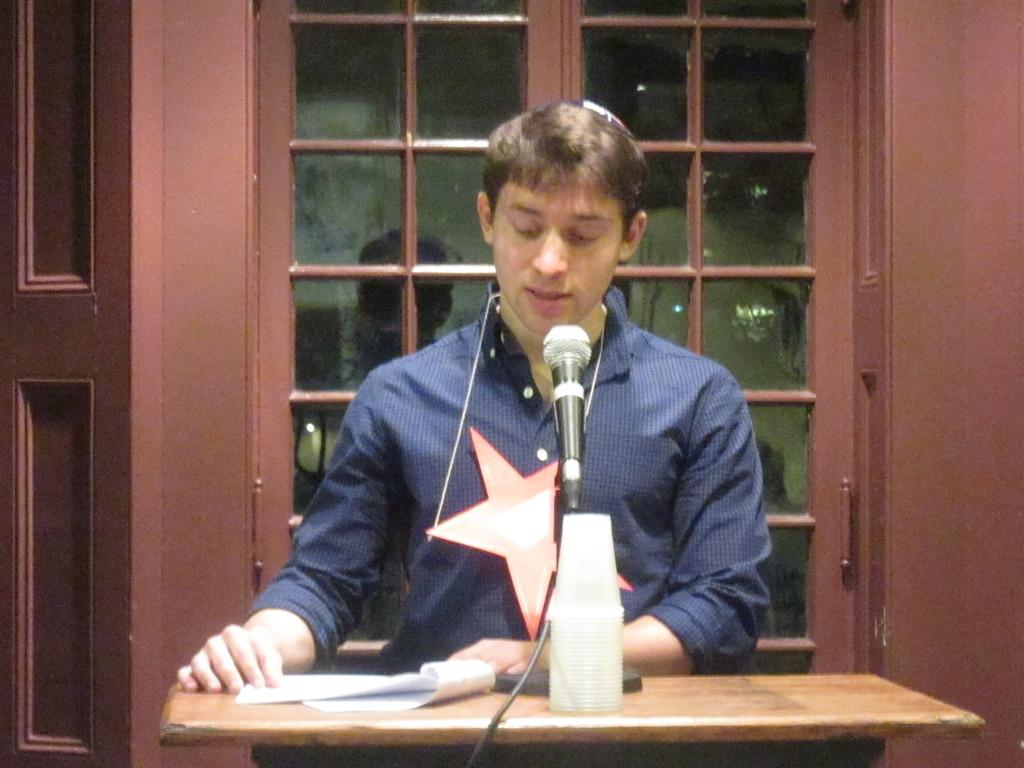What is the man in the image doing? The man is speaking at a podium. What is in front of the man to help amplify his voice? There is a microphone in front of the man. What might the man be referring to while speaking at the podium? The man has papers in front of him, which might contain notes or a speech. Can you see any dinosaurs walking in the stream behind the man in the image? There are no dinosaurs or streams present in the image. What type of plastic objects are visible in the image? There are no plastic objects visible in the image. 